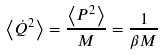Convert formula to latex. <formula><loc_0><loc_0><loc_500><loc_500>\left \langle \dot { Q } ^ { 2 } \right \rangle = \frac { \left \langle P ^ { 2 } \right \rangle } { M } = \frac { 1 } { \beta M }</formula> 